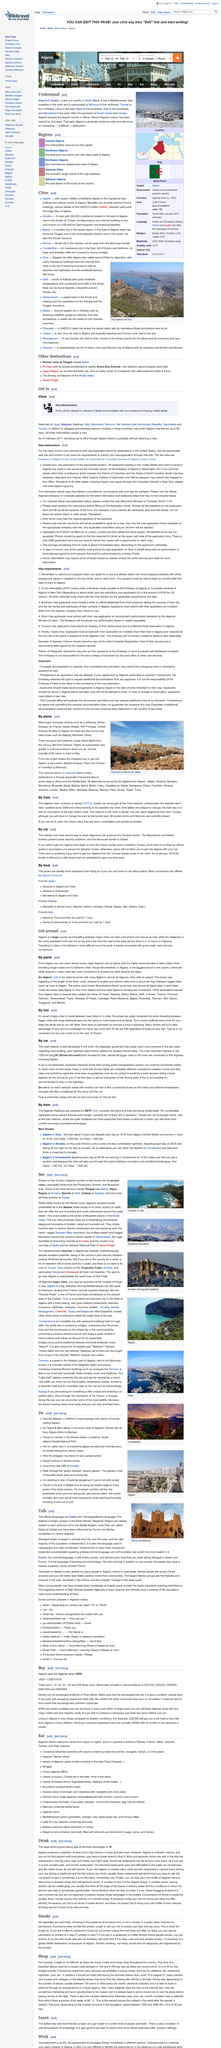List a handful of essential elements in this visual. It is a fact that visiting the Kasbah and traveling on camels in the Sahara desert are both things to do. Central Algeria is the region where the metropolitan area around the capital is located. It is commonly referred to as the capital's metropolitan area. It is a fact that Algiers is one of the places where cable cars can be found. Algeria's greatest tourist attraction is the Sahara. Nationals of Libya are able to enter Algeria visa-free for a period of up to 90 days. 